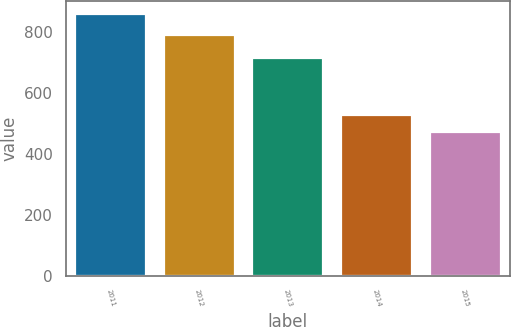Convert chart. <chart><loc_0><loc_0><loc_500><loc_500><bar_chart><fcel>2011<fcel>2012<fcel>2013<fcel>2014<fcel>2015<nl><fcel>859<fcel>793<fcel>715<fcel>530<fcel>474<nl></chart> 